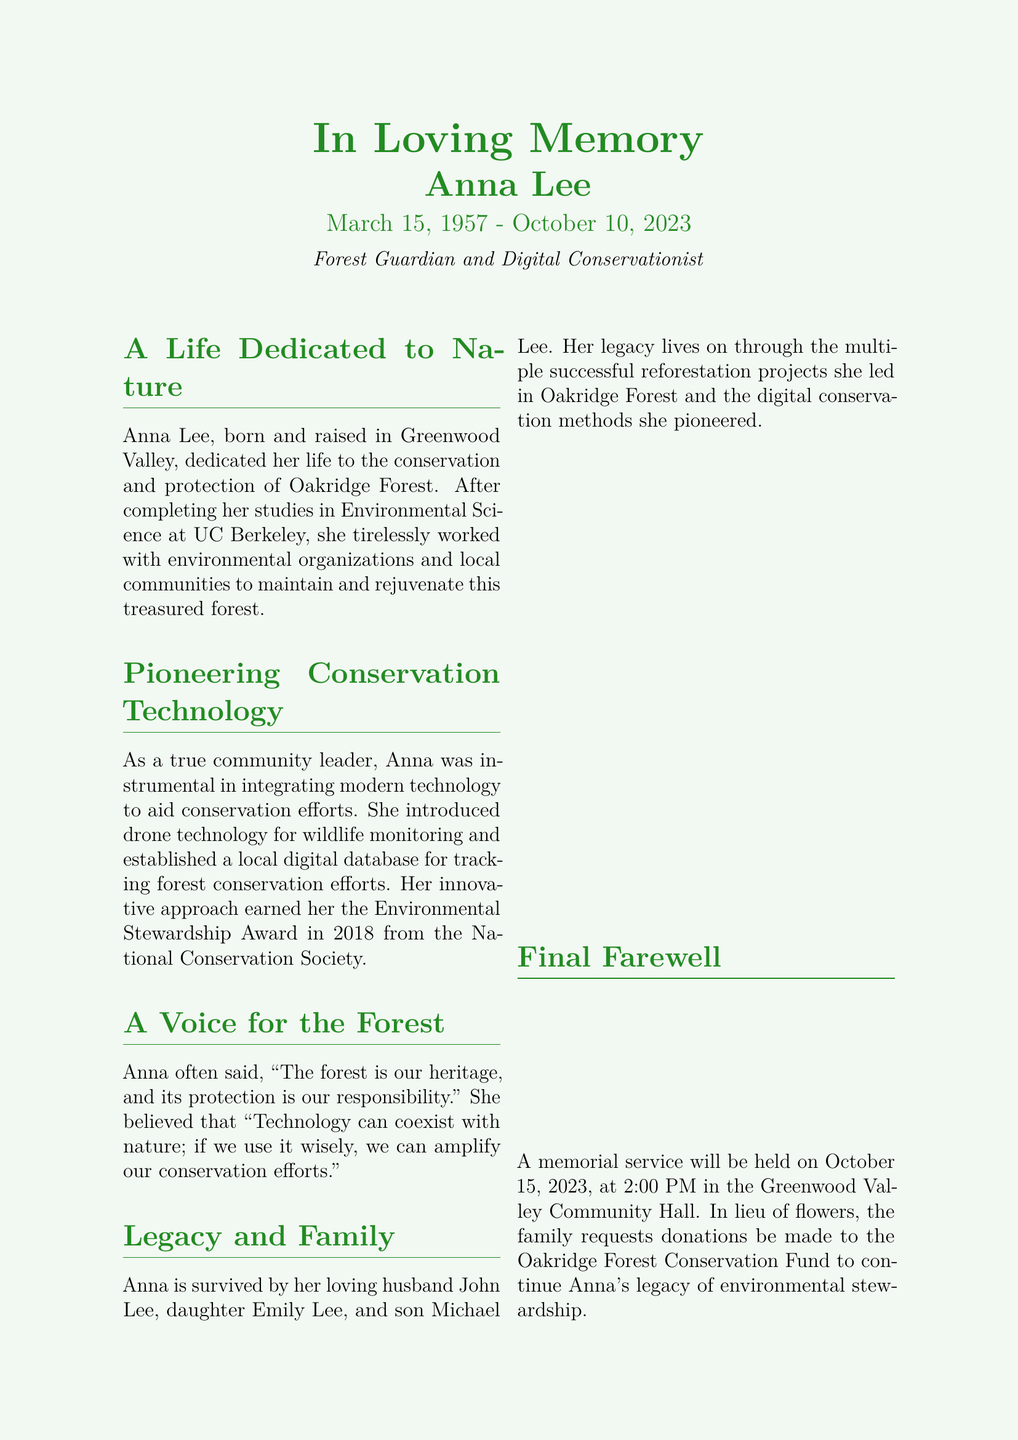What was Anna Lee's birth date? Anna's birth date is explicitly stated in the document.
Answer: March 15, 1957 What is the title given to Anna Lee? The document states Anna's title as well as her contributions.
Answer: Forest Guardian and Digital Conservationist What date did Anna Lee pass away? The document includes the date of her passing.
Answer: October 10, 2023 How many children did Anna Lee have? The document lists family members, including her children.
Answer: Two What award did Anna receive in 2018? The document mentions an award she earned and its name.
Answer: Environmental Stewardship Award What was Anna's major field of study? The document specifies Anna's area of education.
Answer: Environmental Science What was the name of Anna's husband? The document provides the name of her husband as part of her family legacy.
Answer: John Lee What is the purpose of the memorial service? The document describes the memorial service and its intention.
Answer: To honor Anna Lee What organization is suggested for donations in lieu of flowers? The document includes a specific fund for donations in memory of Anna.
Answer: Oakridge Forest Conservation Fund What technology did Anna introduce for wildlife monitoring? The document highlights a specific technology she utilized in her efforts.
Answer: Drone technology 